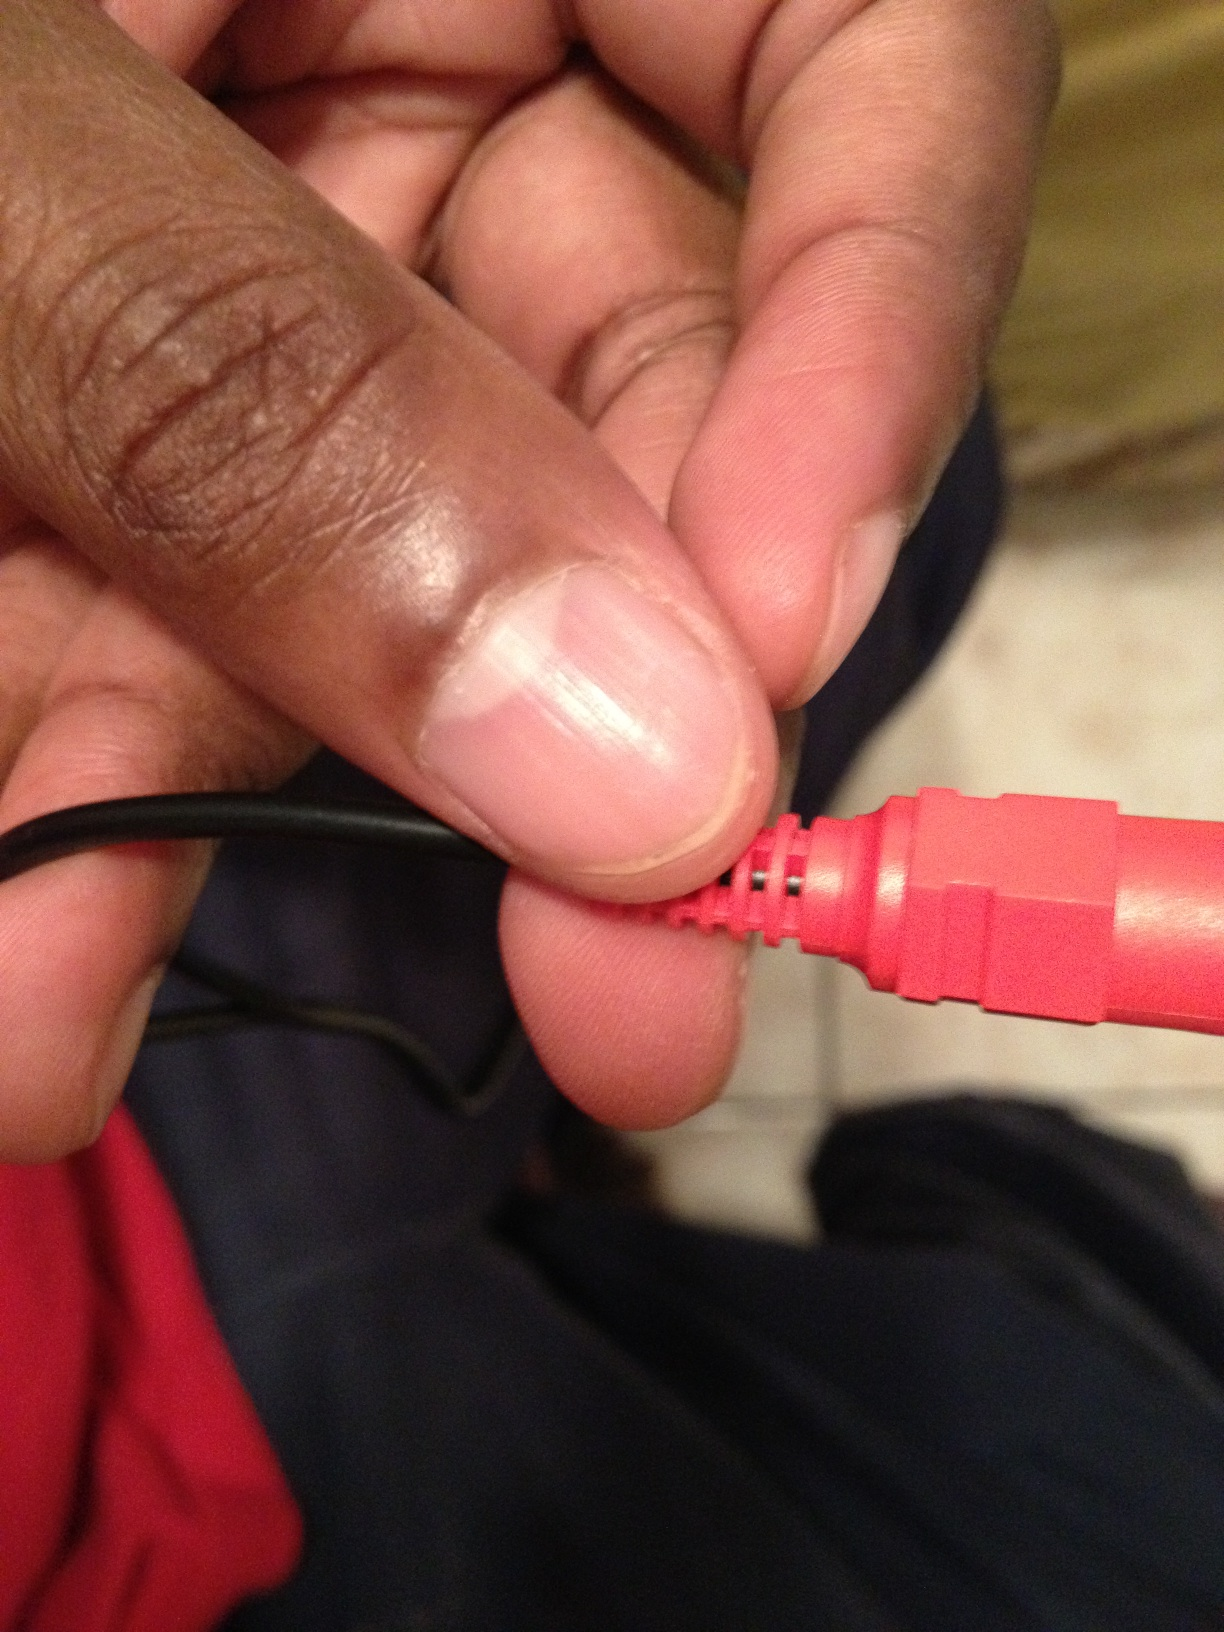Could you please tell me what is this? Thank you. This appears to be a close-up of a hand holding a red cable connector pin. It could be an audio jack, an auxiliary cable, or a specific type of connector used for electronics. 